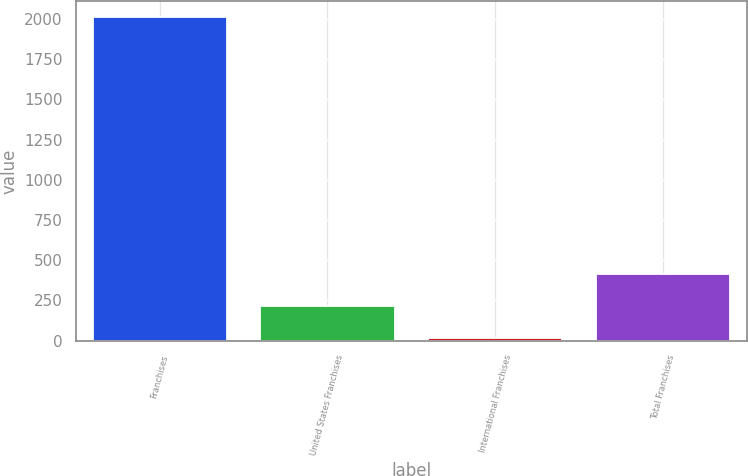<chart> <loc_0><loc_0><loc_500><loc_500><bar_chart><fcel>Franchises<fcel>United States Franchises<fcel>International Franchises<fcel>Total Franchises<nl><fcel>2010<fcel>215.4<fcel>16<fcel>414.8<nl></chart> 